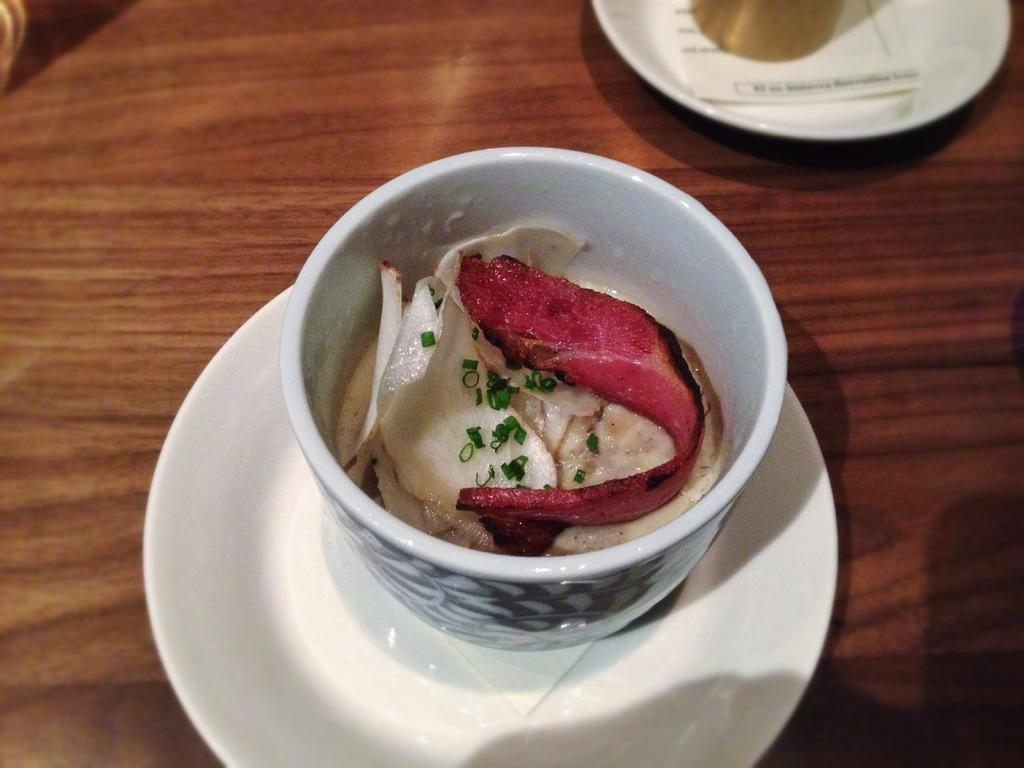What is contained within the cup in the image? There are food items in a cup. Is the cup placed on any other object in the image? Yes, the cup is on a saucer. Where is the cart located in the image? There is no cart present in the image. What type of kitty can be seen playing with the food items in the cup? There is no kitty present in the image; it only features a cup with food items and a saucer. 